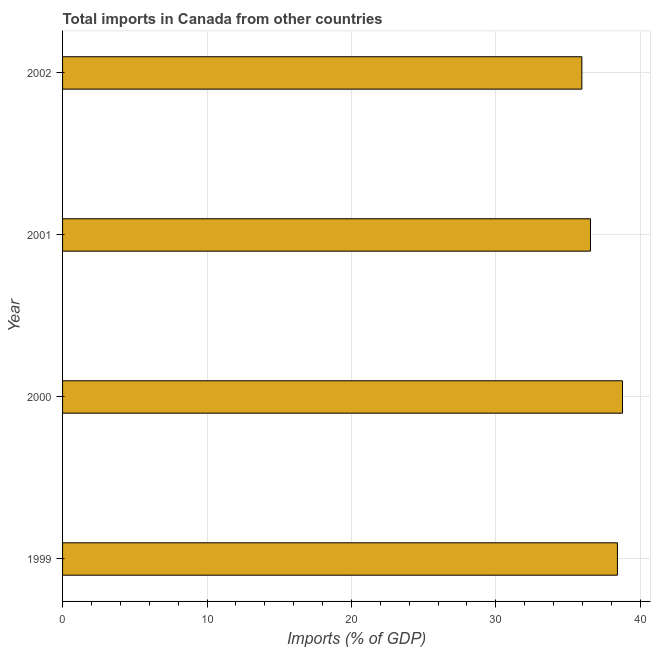What is the title of the graph?
Offer a very short reply. Total imports in Canada from other countries. What is the label or title of the X-axis?
Provide a short and direct response. Imports (% of GDP). What is the label or title of the Y-axis?
Provide a succinct answer. Year. What is the total imports in 2000?
Offer a very short reply. 38.77. Across all years, what is the maximum total imports?
Offer a terse response. 38.77. Across all years, what is the minimum total imports?
Offer a terse response. 35.96. What is the sum of the total imports?
Keep it short and to the point. 149.69. What is the difference between the total imports in 1999 and 2002?
Make the answer very short. 2.46. What is the average total imports per year?
Keep it short and to the point. 37.42. What is the median total imports?
Make the answer very short. 37.48. In how many years, is the total imports greater than 24 %?
Offer a terse response. 4. What is the ratio of the total imports in 2000 to that in 2001?
Your answer should be very brief. 1.06. What is the difference between the highest and the second highest total imports?
Offer a terse response. 0.35. Is the sum of the total imports in 1999 and 2000 greater than the maximum total imports across all years?
Offer a very short reply. Yes. What is the difference between the highest and the lowest total imports?
Offer a very short reply. 2.81. How many bars are there?
Your response must be concise. 4. How many years are there in the graph?
Your answer should be very brief. 4. What is the difference between two consecutive major ticks on the X-axis?
Your answer should be compact. 10. What is the Imports (% of GDP) in 1999?
Offer a very short reply. 38.42. What is the Imports (% of GDP) of 2000?
Offer a very short reply. 38.77. What is the Imports (% of GDP) of 2001?
Provide a short and direct response. 36.55. What is the Imports (% of GDP) in 2002?
Make the answer very short. 35.96. What is the difference between the Imports (% of GDP) in 1999 and 2000?
Your response must be concise. -0.35. What is the difference between the Imports (% of GDP) in 1999 and 2001?
Offer a terse response. 1.86. What is the difference between the Imports (% of GDP) in 1999 and 2002?
Ensure brevity in your answer.  2.46. What is the difference between the Imports (% of GDP) in 2000 and 2001?
Offer a terse response. 2.22. What is the difference between the Imports (% of GDP) in 2000 and 2002?
Give a very brief answer. 2.81. What is the difference between the Imports (% of GDP) in 2001 and 2002?
Make the answer very short. 0.6. What is the ratio of the Imports (% of GDP) in 1999 to that in 2001?
Your answer should be very brief. 1.05. What is the ratio of the Imports (% of GDP) in 1999 to that in 2002?
Offer a terse response. 1.07. What is the ratio of the Imports (% of GDP) in 2000 to that in 2001?
Make the answer very short. 1.06. What is the ratio of the Imports (% of GDP) in 2000 to that in 2002?
Offer a very short reply. 1.08. 